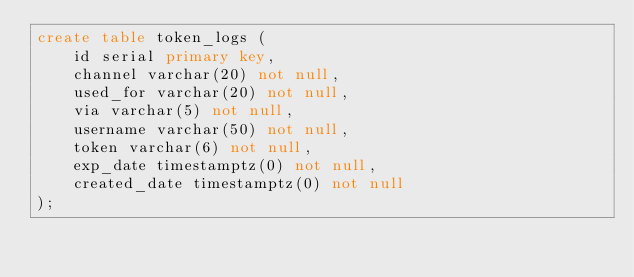Convert code to text. <code><loc_0><loc_0><loc_500><loc_500><_SQL_>create table token_logs (
    id serial primary key,
    channel varchar(20) not null,
    used_for varchar(20) not null, 
    via varchar(5) not null,
    username varchar(50) not null,
    token varchar(6) not null,
    exp_date timestamptz(0) not null,
    created_date timestamptz(0) not null
);</code> 